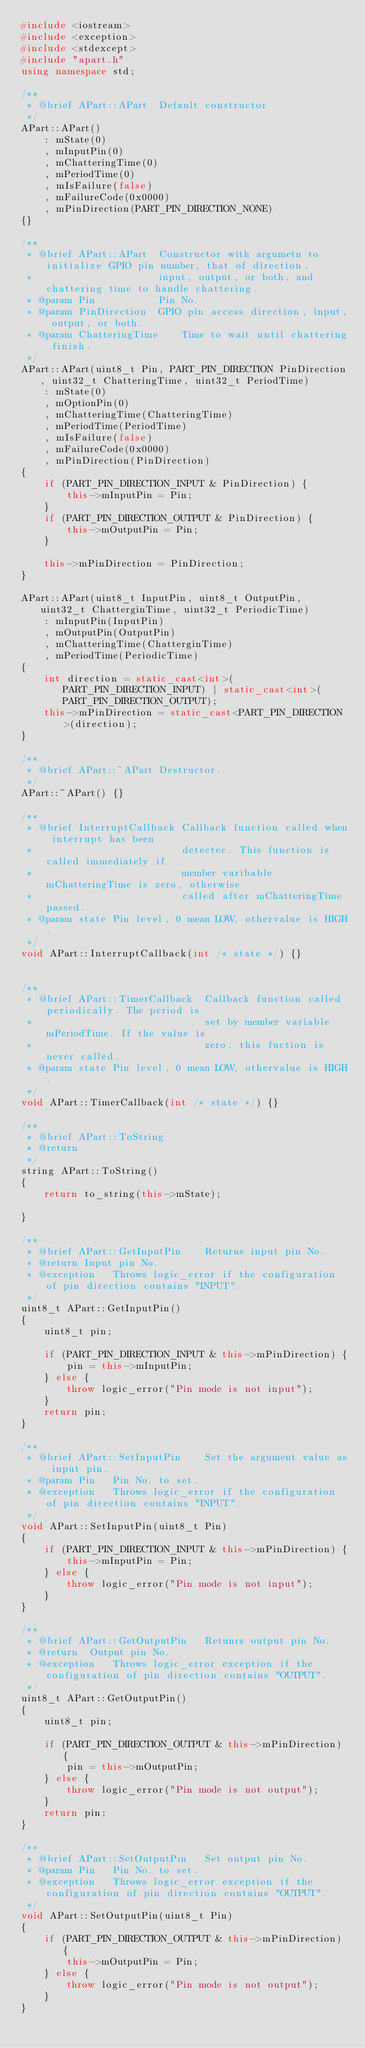Convert code to text. <code><loc_0><loc_0><loc_500><loc_500><_C++_>#include <iostream>
#include <exception>
#include <stdexcept>
#include "apart.h"
using namespace std;

/**
 * @brief APart::APart  Default constructor
 */
APart::APart()
    : mState(0)
    , mInputPin(0)
    , mChatteringTime(0)
    , mPeriodTime(0)
    , mIsFailure(false)
    , mFailureCode(0x0000)
    , mPinDirection(PART_PIN_DIRECTION_NONE)
{}

/**
 * @brief APart::APart  Constructor with argumetn to initialize GPIO pin number, that of direction,
 *                      input, output, or both, and chattering time to handle chattering.
 * @param Pin           Pin No.
 * @param PinDirection  GPIO pin access direction, input, output, or both.
 * @param ChatteringTime    Time to wait until chattering finish.
 */
APart::APart(uint8_t Pin, PART_PIN_DIRECTION PinDirection, uint32_t ChatteringTime, uint32_t PeriodTime)
    : mState(0)
    , mOptionPin(0)
    , mChatteringTime(ChatteringTime)
    , mPeriodTime(PeriodTime)
    , mIsFailure(false)
    , mFailureCode(0x0000)
    , mPinDirection(PinDirection)
{
    if (PART_PIN_DIRECTION_INPUT & PinDirection) {
        this->mInputPin = Pin;
    }
    if (PART_PIN_DIRECTION_OUTPUT & PinDirection) {
        this->mOutputPin = Pin;
    }

    this->mPinDirection = PinDirection;
}

APart::APart(uint8_t InputPin, uint8_t OutputPin, uint32_t ChatterginTime, uint32_t PeriodicTime)
    : mInputPin(InputPin)
    , mOutputPin(OutputPin)
    , mChatteringTime(ChatterginTime)
    , mPeriodTime(PeriodicTime)
{
    int direction = static_cast<int>(PART_PIN_DIRECTION_INPUT) | static_cast<int>(PART_PIN_DIRECTION_OUTPUT);
    this->mPinDirection = static_cast<PART_PIN_DIRECTION>(direction);
}

/**
 * @brief APart::~APart Destructor.
 */
APart::~APart() {}

/**
 * @brief InterruptCallback Callback function called when interrupt has been
 *                          detectec. This function is called immediately if
 *                          member varibable mChatteringTime is zero, otherwise
 *                          called after mChatteringTime passed.
 * @param state Pin level, 0 mean LOW, othervalue is HIGH.
 */
void APart::InterruptCallback(int /* state */) {}


/**
 * @brief APart::TimerCallback  Callback function called periodically. The period is
 *                              set by member variable mPeriodTime. If the value is
 *                              zero, this fuction is never called.
 * @param state Pin level, 0 mean LOW, othervalue is HIGH.
 */
void APart::TimerCallback(int /* state */) {}

/**
 * @brief APart::ToString
 * @return
 */
string APart::ToString()
{
    return to_string(this->mState);

}

/**
 * @brief APart::GetInputPin    Returns input pin No.
 * @return Input pin No.
 * @exception   Throws logic_error if the configuration of pin direction contains "INPUT".
 */
uint8_t APart::GetInputPin()
{
    uint8_t pin;

    if (PART_PIN_DIRECTION_INPUT & this->mPinDirection) {
        pin = this->mInputPin;
    } else {
        throw logic_error("Pin mode is not input");
    }
    return pin;
}

/**
 * @brief APart::SetInputPin    Set the argument value as input pin.
 * @param Pin   Pin No. to set.
 * @exception   Throws logic_error if the configuration of pin direction contains "INPUT".
 */
void APart::SetInputPin(uint8_t Pin)
{
    if (PART_PIN_DIRECTION_INPUT & this->mPinDirection) {
        this->mInputPin = Pin;
    } else {
        throw logic_error("Pin mode is not input");
    }
}

/**
 * @brief APart::GetOutputPin   Retunrs output pin No.
 * @return  Output pin No.
 * @exception   Throws logic_error exception if the configuration of pin direction contains "OUTPUT".
 */
uint8_t APart::GetOutputPin()
{
    uint8_t pin;

    if (PART_PIN_DIRECTION_OUTPUT & this->mPinDirection) {
        pin = this->mOutputPin;
    } else {
        throw logic_error("Pin mode is not output");
    }
    return pin;
}

/**
 * @brief APart::SetOutputPin   Set output pin No.
 * @param Pin   Pin No. to set.
 * @exception   Throws logic_error exception if the configuration of pin direction contains "OUTPUT".
 */
void APart::SetOutputPin(uint8_t Pin)
{
    if (PART_PIN_DIRECTION_OUTPUT & this->mPinDirection) {
        this->mOutputPin = Pin;
    } else {
        throw logic_error("Pin mode is not output");
    }
}
</code> 